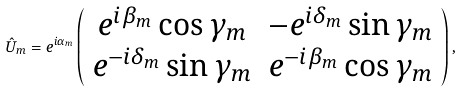Convert formula to latex. <formula><loc_0><loc_0><loc_500><loc_500>\hat { U } _ { m } = e ^ { i \alpha _ { m } } \left ( \begin{array} { c c } e ^ { i \beta _ { m } } \cos \gamma _ { m } & - e ^ { i \delta _ { m } } \sin \gamma _ { m } \\ e ^ { - i \delta _ { m } } \sin \gamma _ { m } & e ^ { - i \beta _ { m } } \cos \gamma _ { m } \end{array} \right ) ,</formula> 